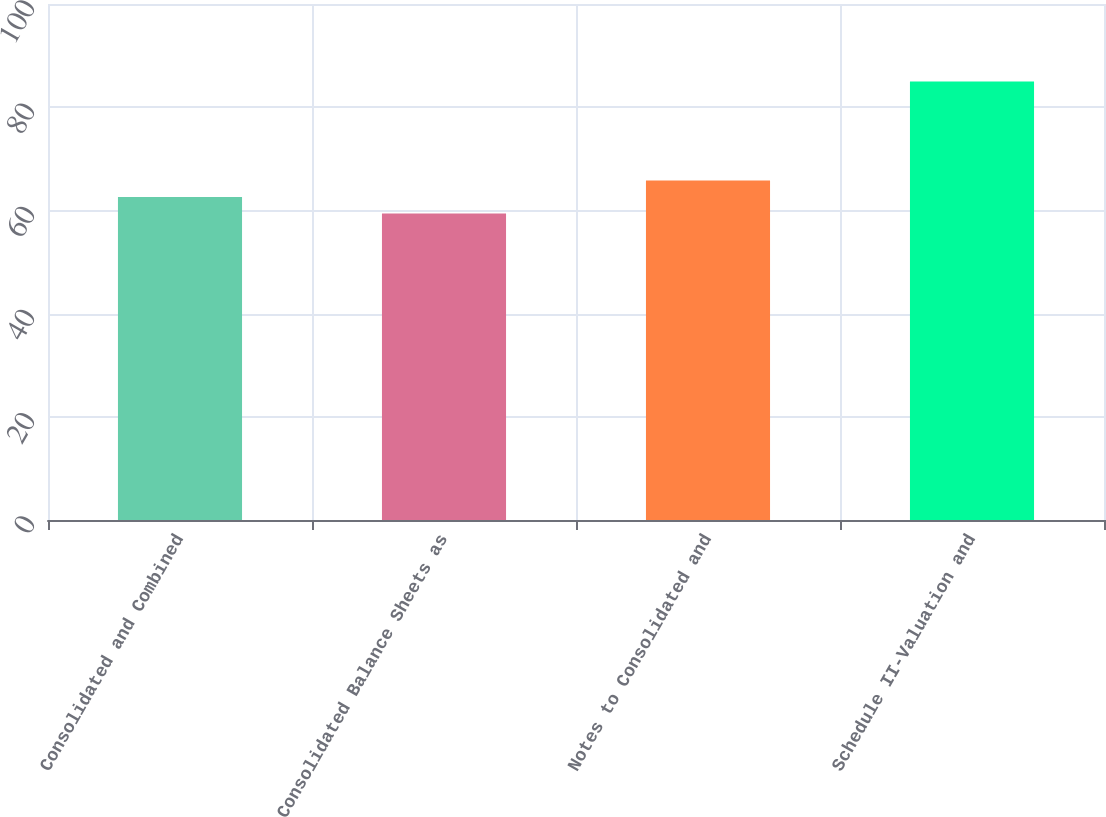Convert chart. <chart><loc_0><loc_0><loc_500><loc_500><bar_chart><fcel>Consolidated and Combined<fcel>Consolidated Balance Sheets as<fcel>Notes to Consolidated and<fcel>Schedule II-Valuation and<nl><fcel>62.6<fcel>59.4<fcel>65.8<fcel>85<nl></chart> 